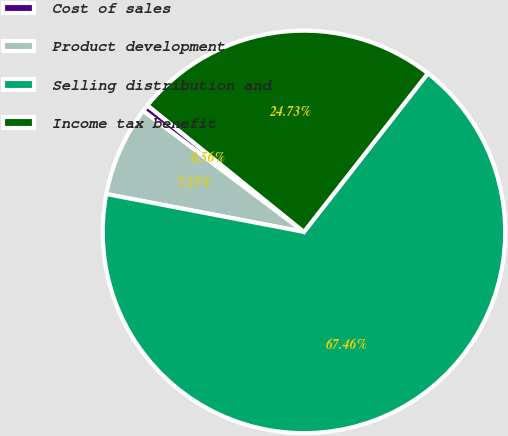<chart> <loc_0><loc_0><loc_500><loc_500><pie_chart><fcel>Cost of sales<fcel>Product development<fcel>Selling distribution and<fcel>Income tax benefit<nl><fcel>0.56%<fcel>7.25%<fcel>67.45%<fcel>24.73%<nl></chart> 